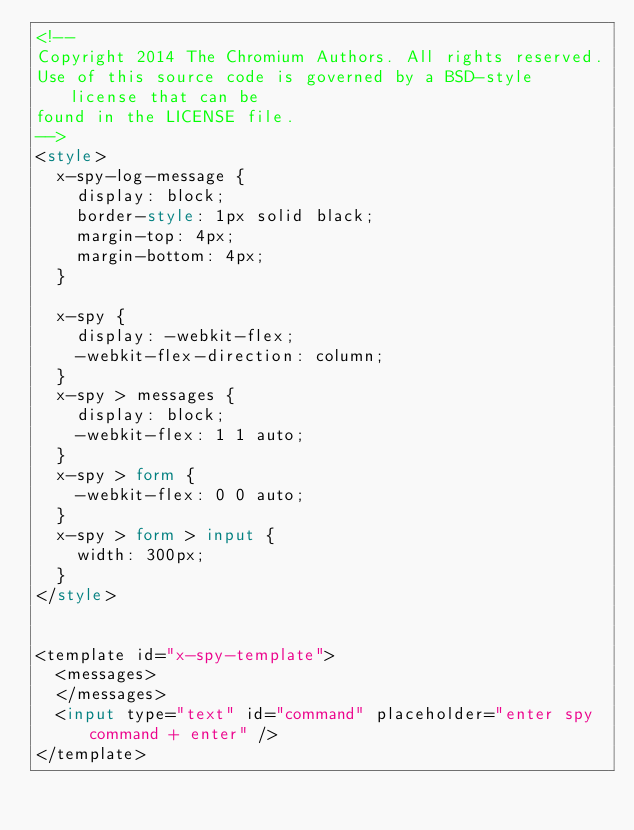<code> <loc_0><loc_0><loc_500><loc_500><_HTML_><!--
Copyright 2014 The Chromium Authors. All rights reserved.
Use of this source code is governed by a BSD-style license that can be
found in the LICENSE file.
-->
<style>
  x-spy-log-message {
    display: block;
    border-style: 1px solid black;
    margin-top: 4px;
    margin-bottom: 4px;
  }

  x-spy {
    display: -webkit-flex;
    -webkit-flex-direction: column;
  }
  x-spy > messages {
    display: block;
    -webkit-flex: 1 1 auto;
  }
  x-spy > form {
    -webkit-flex: 0 0 auto;
  }
  x-spy > form > input {
    width: 300px;
  }
</style>


<template id="x-spy-template">
  <messages>
  </messages>
  <input type="text" id="command" placeholder="enter spy command + enter" />
</template>
</code> 